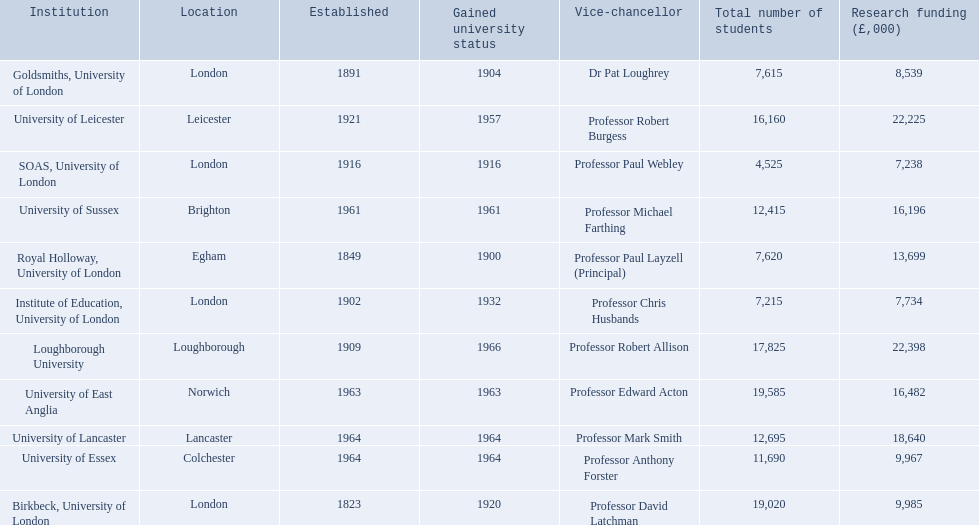What are the names of all the institutions? Birkbeck, University of London, University of East Anglia, University of Essex, Goldsmiths, University of London, Institute of Education, University of London, University of Lancaster, University of Leicester, Loughborough University, Royal Holloway, University of London, SOAS, University of London, University of Sussex. In what range of years were these institutions established? 1823, 1963, 1964, 1891, 1902, 1964, 1921, 1909, 1849, 1916, 1961. In what range of years did these institutions gain university status? 1920, 1963, 1964, 1904, 1932, 1964, 1957, 1966, 1900, 1916, 1961. What institution most recently gained university status? Loughborough University. 